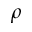<formula> <loc_0><loc_0><loc_500><loc_500>\rho</formula> 